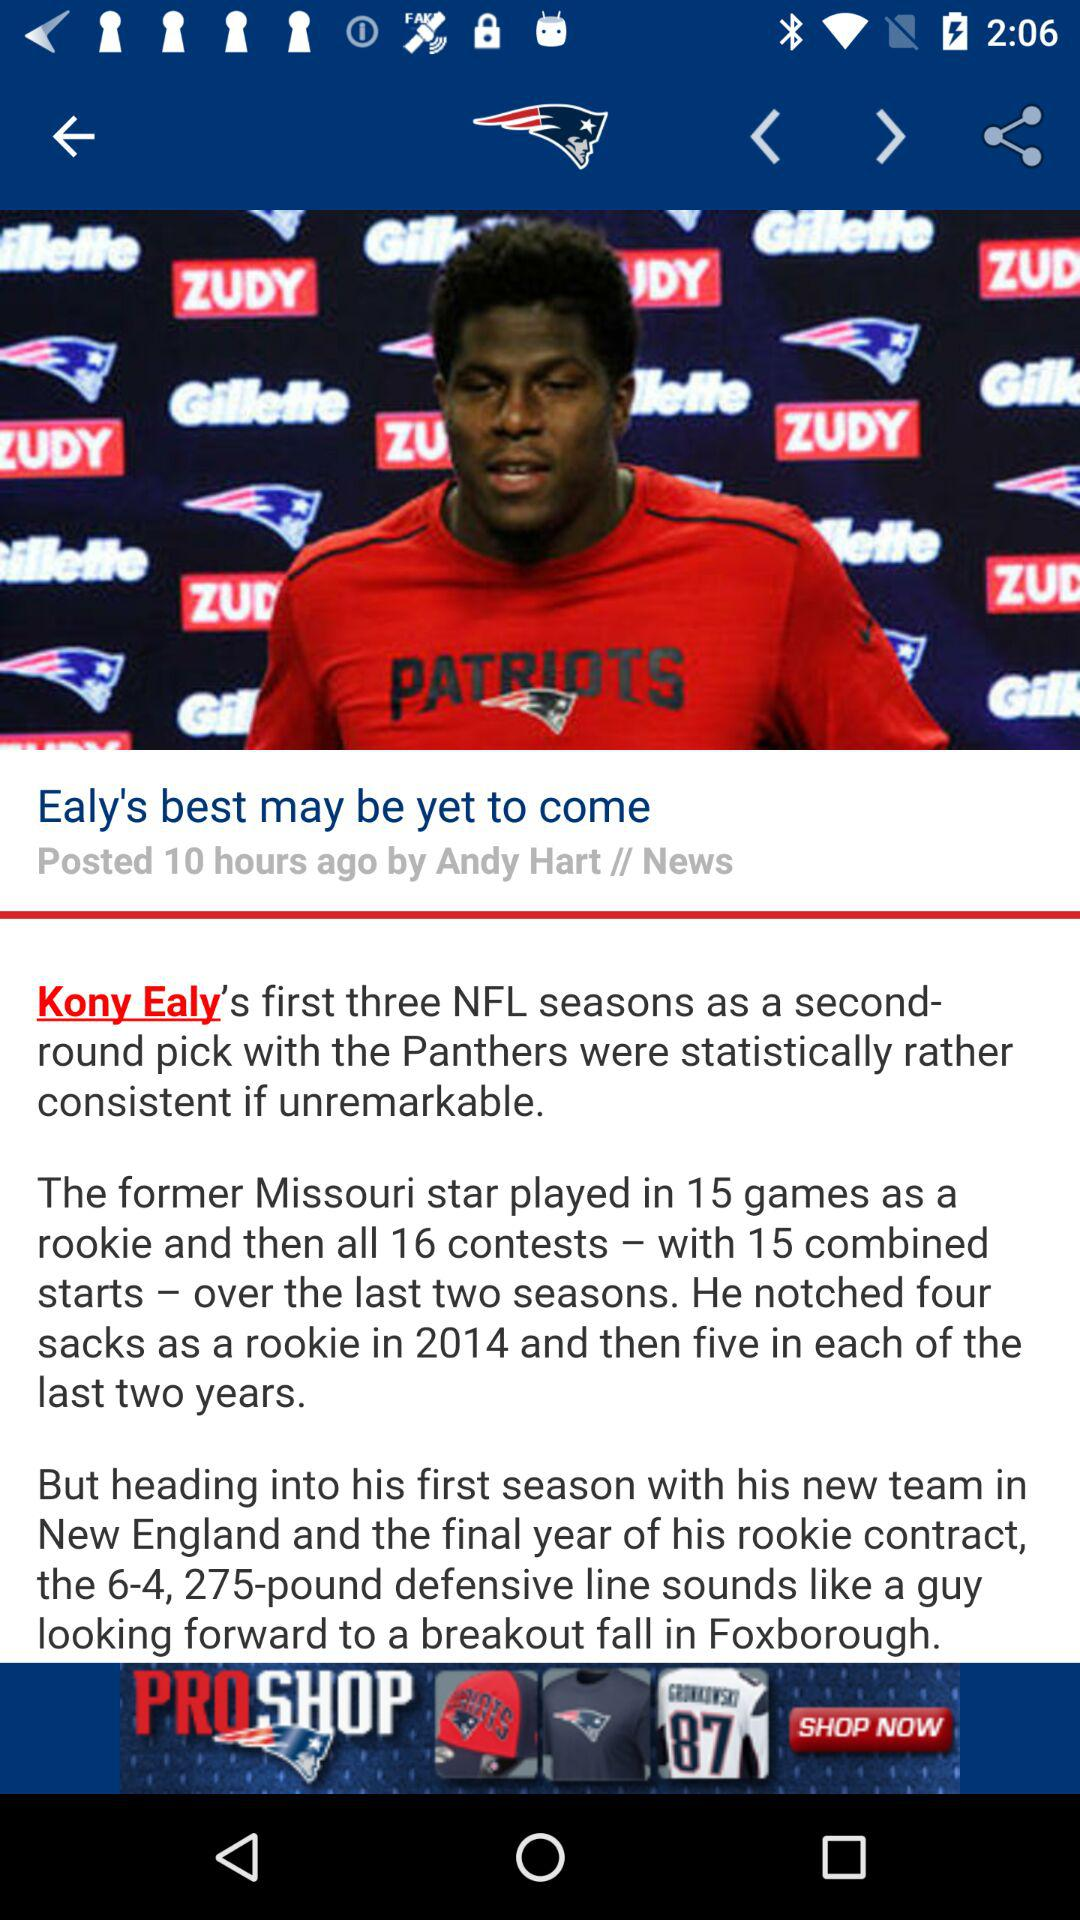How many more sacks did Ealy have in 2016 than 2014?
Answer the question using a single word or phrase. 1 